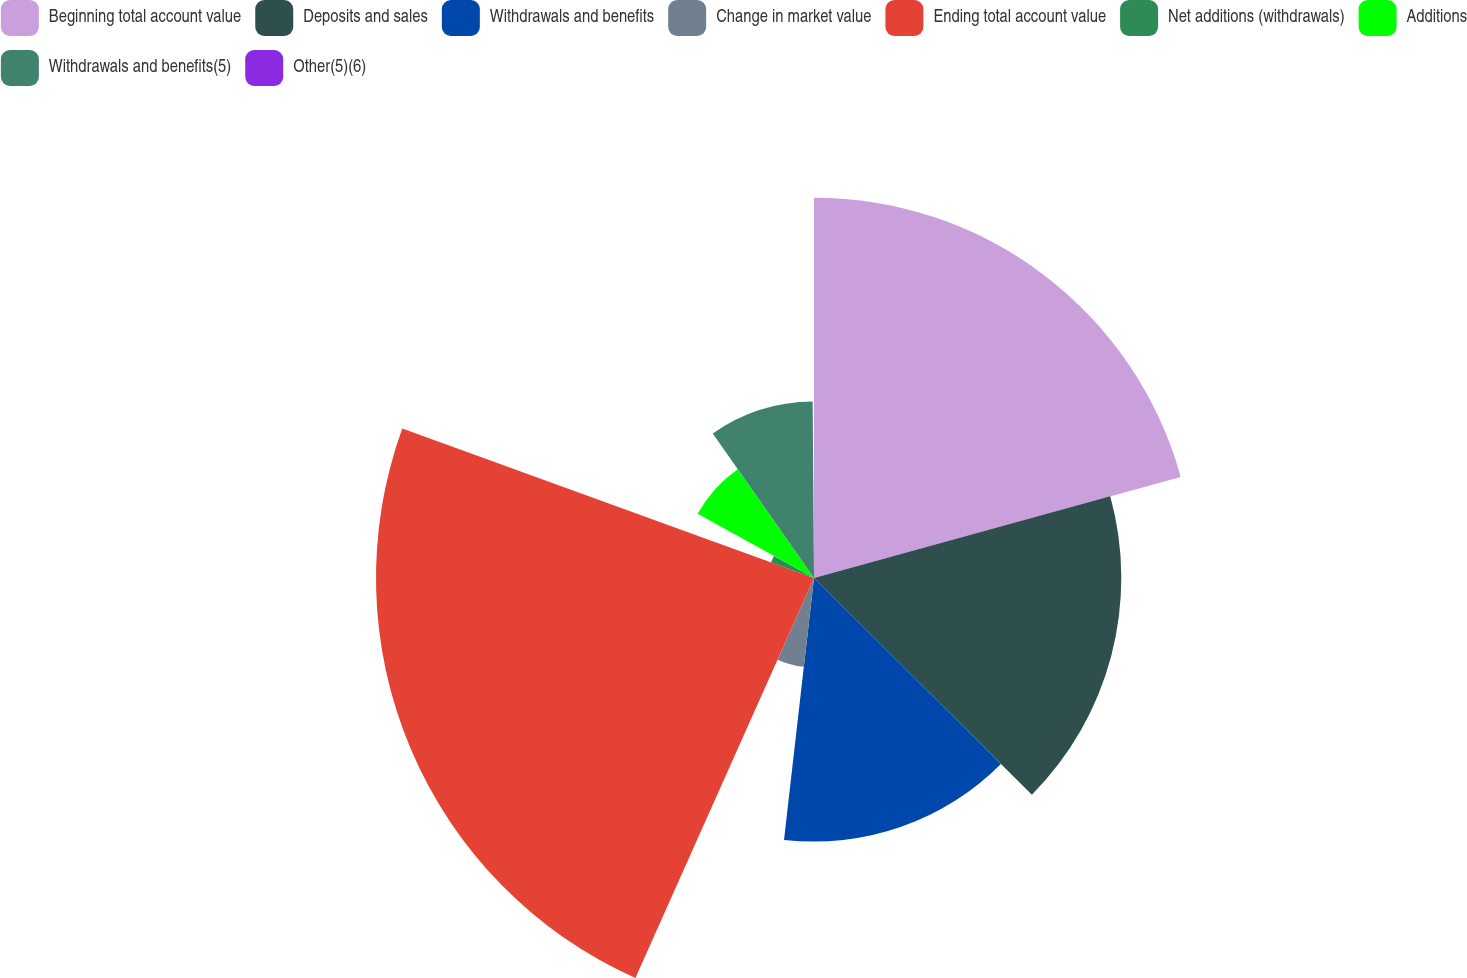Convert chart. <chart><loc_0><loc_0><loc_500><loc_500><pie_chart><fcel>Beginning total account value<fcel>Deposits and sales<fcel>Withdrawals and benefits<fcel>Change in market value<fcel>Ending total account value<fcel>Net additions (withdrawals)<fcel>Additions<fcel>Withdrawals and benefits(5)<fcel>Other(5)(6)<nl><fcel>20.72%<fcel>16.74%<fcel>14.36%<fcel>4.87%<fcel>23.86%<fcel>2.49%<fcel>7.24%<fcel>9.61%<fcel>0.12%<nl></chart> 